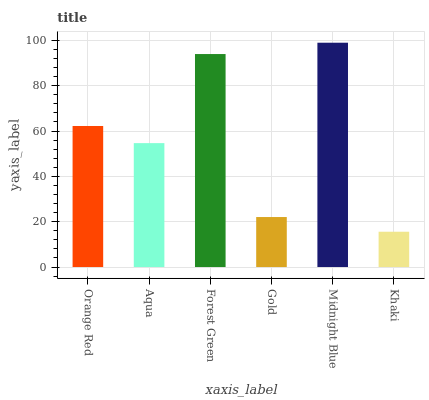Is Khaki the minimum?
Answer yes or no. Yes. Is Midnight Blue the maximum?
Answer yes or no. Yes. Is Aqua the minimum?
Answer yes or no. No. Is Aqua the maximum?
Answer yes or no. No. Is Orange Red greater than Aqua?
Answer yes or no. Yes. Is Aqua less than Orange Red?
Answer yes or no. Yes. Is Aqua greater than Orange Red?
Answer yes or no. No. Is Orange Red less than Aqua?
Answer yes or no. No. Is Orange Red the high median?
Answer yes or no. Yes. Is Aqua the low median?
Answer yes or no. Yes. Is Gold the high median?
Answer yes or no. No. Is Gold the low median?
Answer yes or no. No. 